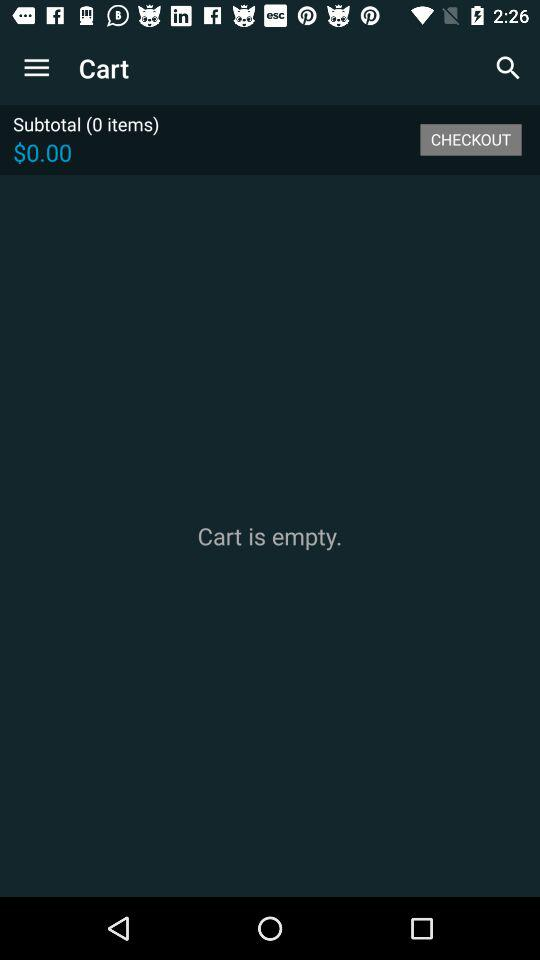What is the subtotal? The subtotal is $0. 